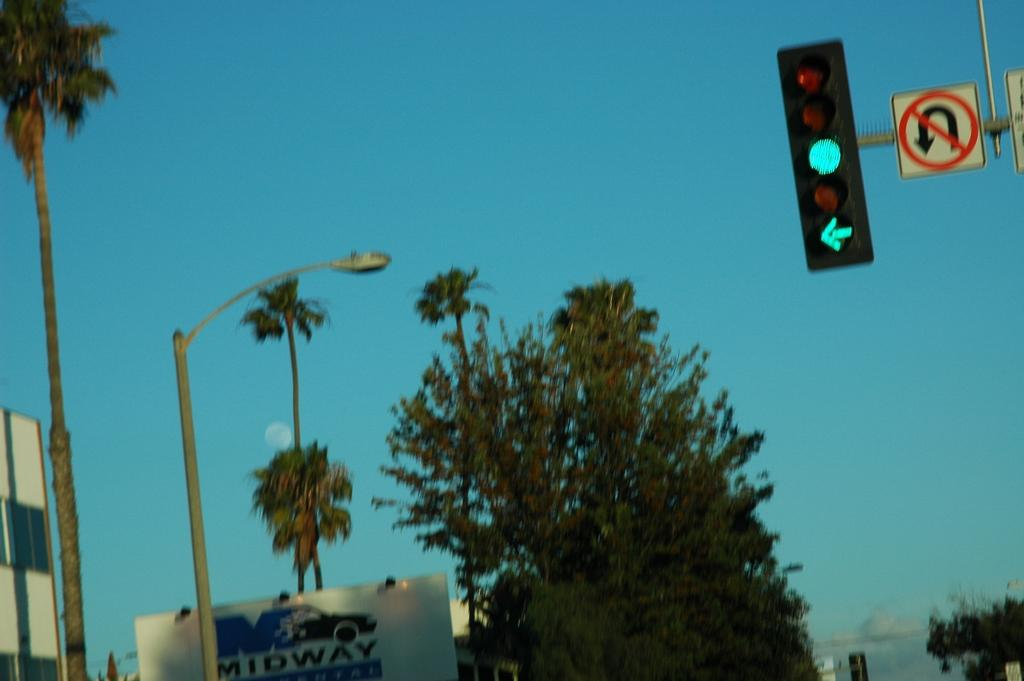<image>
Offer a succinct explanation of the picture presented. A green light with a no uturn sign above a sign that says Midway. 